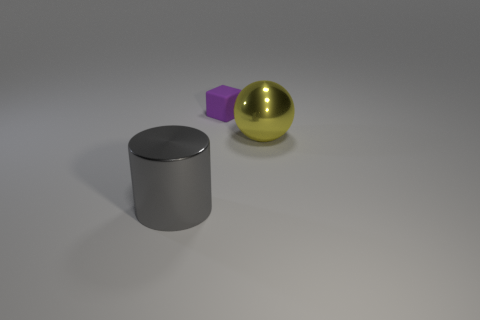Add 2 big yellow things. How many objects exist? 5 Subtract 1 cylinders. How many cylinders are left? 0 Subtract all cylinders. How many objects are left? 2 Subtract all red cylinders. How many blue cubes are left? 0 Subtract all large yellow rubber objects. Subtract all small purple objects. How many objects are left? 2 Add 3 big metal cylinders. How many big metal cylinders are left? 4 Add 3 brown matte things. How many brown matte things exist? 3 Subtract 0 yellow cylinders. How many objects are left? 3 